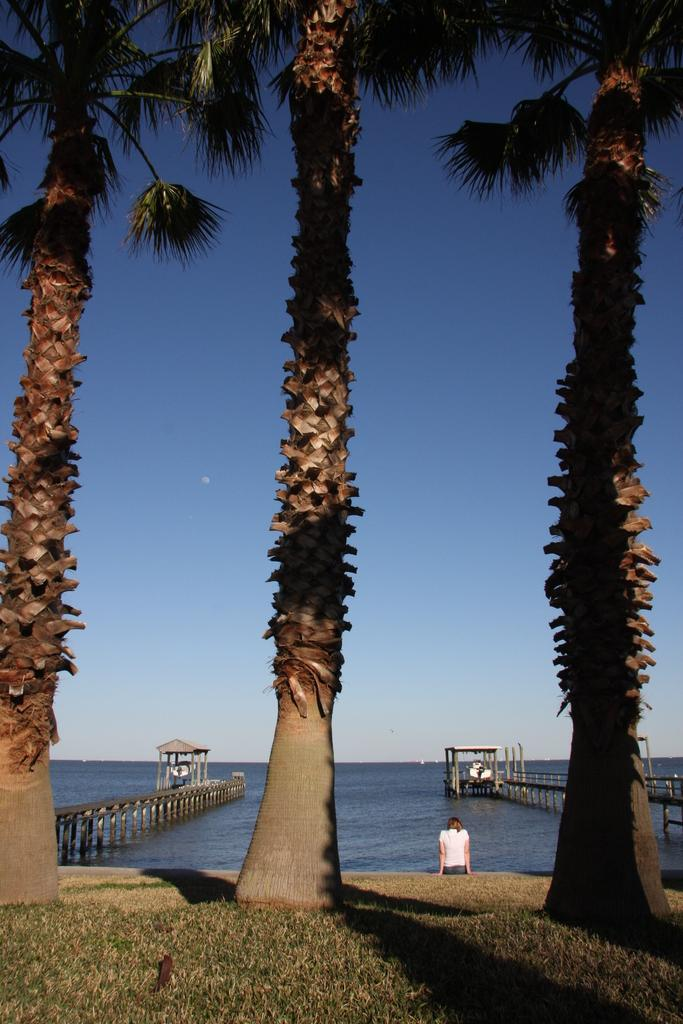What type of natural elements can be seen in the image? There are trees in the image. What is the person in the image doing? The person is sitting on the ground in the image. What can be seen in the water in the image? There are bridges in the image. What structures are present on the bridges? There are sheds on the bridges. What is visible in the background of the image? The sky is visible in the background of the image. What type of toy can be seen floating in the water in the image? There is no toy visible in the water in the image. What color is the mitten that the person is wearing in the image? The person in the image is not wearing a mitten, so we cannot determine its color. 